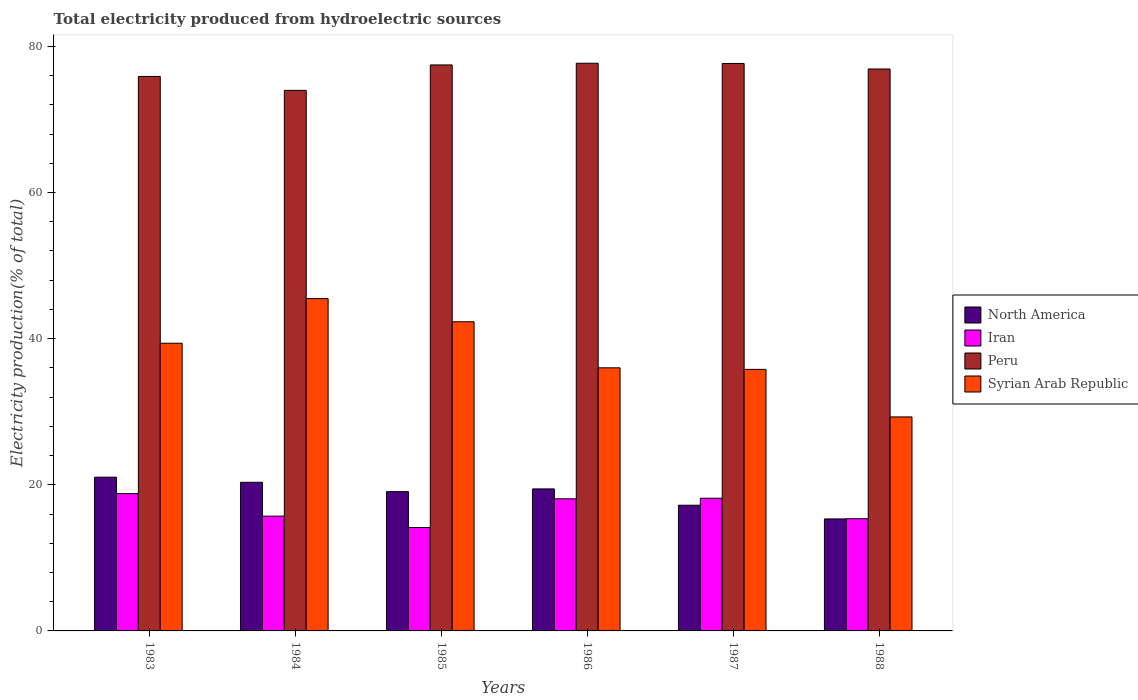How many different coloured bars are there?
Provide a short and direct response. 4. How many groups of bars are there?
Your answer should be compact. 6. Are the number of bars per tick equal to the number of legend labels?
Offer a very short reply. Yes. Are the number of bars on each tick of the X-axis equal?
Make the answer very short. Yes. How many bars are there on the 3rd tick from the right?
Your answer should be compact. 4. In how many cases, is the number of bars for a given year not equal to the number of legend labels?
Your answer should be very brief. 0. What is the total electricity produced in Iran in 1988?
Your answer should be compact. 15.36. Across all years, what is the maximum total electricity produced in Syrian Arab Republic?
Keep it short and to the point. 45.49. Across all years, what is the minimum total electricity produced in Syrian Arab Republic?
Ensure brevity in your answer.  29.29. What is the total total electricity produced in Iran in the graph?
Keep it short and to the point. 100.26. What is the difference between the total electricity produced in Iran in 1983 and that in 1986?
Offer a very short reply. 0.71. What is the difference between the total electricity produced in North America in 1987 and the total electricity produced in Iran in 1985?
Offer a terse response. 3.05. What is the average total electricity produced in Syrian Arab Republic per year?
Offer a very short reply. 38.05. In the year 1983, what is the difference between the total electricity produced in Syrian Arab Republic and total electricity produced in Iran?
Offer a terse response. 20.58. What is the ratio of the total electricity produced in Iran in 1984 to that in 1987?
Your answer should be compact. 0.87. Is the difference between the total electricity produced in Syrian Arab Republic in 1983 and 1985 greater than the difference between the total electricity produced in Iran in 1983 and 1985?
Your answer should be very brief. No. What is the difference between the highest and the second highest total electricity produced in Peru?
Offer a very short reply. 0.03. What is the difference between the highest and the lowest total electricity produced in Peru?
Your response must be concise. 3.71. Is it the case that in every year, the sum of the total electricity produced in Iran and total electricity produced in North America is greater than the sum of total electricity produced in Peru and total electricity produced in Syrian Arab Republic?
Offer a terse response. No. Is it the case that in every year, the sum of the total electricity produced in Peru and total electricity produced in Syrian Arab Republic is greater than the total electricity produced in Iran?
Offer a terse response. Yes. What is the difference between two consecutive major ticks on the Y-axis?
Your answer should be compact. 20. Does the graph contain any zero values?
Your answer should be very brief. No. Does the graph contain grids?
Your answer should be very brief. No. What is the title of the graph?
Offer a terse response. Total electricity produced from hydroelectric sources. Does "Virgin Islands" appear as one of the legend labels in the graph?
Provide a short and direct response. No. What is the label or title of the Y-axis?
Make the answer very short. Electricity production(% of total). What is the Electricity production(% of total) of North America in 1983?
Ensure brevity in your answer.  21.04. What is the Electricity production(% of total) in Iran in 1983?
Offer a very short reply. 18.79. What is the Electricity production(% of total) of Peru in 1983?
Your response must be concise. 75.89. What is the Electricity production(% of total) in Syrian Arab Republic in 1983?
Ensure brevity in your answer.  39.38. What is the Electricity production(% of total) of North America in 1984?
Keep it short and to the point. 20.34. What is the Electricity production(% of total) in Iran in 1984?
Give a very brief answer. 15.71. What is the Electricity production(% of total) of Peru in 1984?
Ensure brevity in your answer.  73.99. What is the Electricity production(% of total) in Syrian Arab Republic in 1984?
Offer a very short reply. 45.49. What is the Electricity production(% of total) in North America in 1985?
Make the answer very short. 19.06. What is the Electricity production(% of total) of Iran in 1985?
Offer a very short reply. 14.15. What is the Electricity production(% of total) in Peru in 1985?
Your answer should be very brief. 77.47. What is the Electricity production(% of total) in Syrian Arab Republic in 1985?
Your response must be concise. 42.31. What is the Electricity production(% of total) of North America in 1986?
Ensure brevity in your answer.  19.44. What is the Electricity production(% of total) in Iran in 1986?
Your answer should be compact. 18.08. What is the Electricity production(% of total) in Peru in 1986?
Keep it short and to the point. 77.7. What is the Electricity production(% of total) in Syrian Arab Republic in 1986?
Ensure brevity in your answer.  36.01. What is the Electricity production(% of total) of North America in 1987?
Your answer should be very brief. 17.2. What is the Electricity production(% of total) of Iran in 1987?
Ensure brevity in your answer.  18.16. What is the Electricity production(% of total) in Peru in 1987?
Provide a succinct answer. 77.67. What is the Electricity production(% of total) in Syrian Arab Republic in 1987?
Provide a short and direct response. 35.8. What is the Electricity production(% of total) in North America in 1988?
Make the answer very short. 15.33. What is the Electricity production(% of total) of Iran in 1988?
Offer a very short reply. 15.36. What is the Electricity production(% of total) in Peru in 1988?
Make the answer very short. 76.91. What is the Electricity production(% of total) in Syrian Arab Republic in 1988?
Provide a succinct answer. 29.29. Across all years, what is the maximum Electricity production(% of total) in North America?
Ensure brevity in your answer.  21.04. Across all years, what is the maximum Electricity production(% of total) in Iran?
Your answer should be very brief. 18.79. Across all years, what is the maximum Electricity production(% of total) of Peru?
Your answer should be compact. 77.7. Across all years, what is the maximum Electricity production(% of total) in Syrian Arab Republic?
Your answer should be compact. 45.49. Across all years, what is the minimum Electricity production(% of total) in North America?
Offer a terse response. 15.33. Across all years, what is the minimum Electricity production(% of total) in Iran?
Keep it short and to the point. 14.15. Across all years, what is the minimum Electricity production(% of total) in Peru?
Provide a short and direct response. 73.99. Across all years, what is the minimum Electricity production(% of total) of Syrian Arab Republic?
Your answer should be compact. 29.29. What is the total Electricity production(% of total) of North America in the graph?
Ensure brevity in your answer.  112.42. What is the total Electricity production(% of total) in Iran in the graph?
Your answer should be very brief. 100.26. What is the total Electricity production(% of total) of Peru in the graph?
Your response must be concise. 459.62. What is the total Electricity production(% of total) in Syrian Arab Republic in the graph?
Provide a succinct answer. 228.28. What is the difference between the Electricity production(% of total) of North America in 1983 and that in 1984?
Offer a terse response. 0.7. What is the difference between the Electricity production(% of total) in Iran in 1983 and that in 1984?
Make the answer very short. 3.08. What is the difference between the Electricity production(% of total) of Peru in 1983 and that in 1984?
Offer a very short reply. 1.91. What is the difference between the Electricity production(% of total) of Syrian Arab Republic in 1983 and that in 1984?
Offer a very short reply. -6.11. What is the difference between the Electricity production(% of total) in North America in 1983 and that in 1985?
Offer a very short reply. 1.98. What is the difference between the Electricity production(% of total) of Iran in 1983 and that in 1985?
Your answer should be compact. 4.64. What is the difference between the Electricity production(% of total) of Peru in 1983 and that in 1985?
Make the answer very short. -1.57. What is the difference between the Electricity production(% of total) in Syrian Arab Republic in 1983 and that in 1985?
Your response must be concise. -2.94. What is the difference between the Electricity production(% of total) in North America in 1983 and that in 1986?
Make the answer very short. 1.61. What is the difference between the Electricity production(% of total) of Iran in 1983 and that in 1986?
Offer a very short reply. 0.71. What is the difference between the Electricity production(% of total) of Peru in 1983 and that in 1986?
Your answer should be compact. -1.8. What is the difference between the Electricity production(% of total) of Syrian Arab Republic in 1983 and that in 1986?
Your answer should be compact. 3.37. What is the difference between the Electricity production(% of total) in North America in 1983 and that in 1987?
Offer a terse response. 3.84. What is the difference between the Electricity production(% of total) in Iran in 1983 and that in 1987?
Your response must be concise. 0.63. What is the difference between the Electricity production(% of total) in Peru in 1983 and that in 1987?
Your response must be concise. -1.77. What is the difference between the Electricity production(% of total) of Syrian Arab Republic in 1983 and that in 1987?
Offer a terse response. 3.58. What is the difference between the Electricity production(% of total) in North America in 1983 and that in 1988?
Make the answer very short. 5.71. What is the difference between the Electricity production(% of total) in Iran in 1983 and that in 1988?
Your response must be concise. 3.43. What is the difference between the Electricity production(% of total) in Peru in 1983 and that in 1988?
Give a very brief answer. -1.02. What is the difference between the Electricity production(% of total) of Syrian Arab Republic in 1983 and that in 1988?
Offer a terse response. 10.09. What is the difference between the Electricity production(% of total) in North America in 1984 and that in 1985?
Give a very brief answer. 1.28. What is the difference between the Electricity production(% of total) of Iran in 1984 and that in 1985?
Make the answer very short. 1.56. What is the difference between the Electricity production(% of total) in Peru in 1984 and that in 1985?
Ensure brevity in your answer.  -3.48. What is the difference between the Electricity production(% of total) in Syrian Arab Republic in 1984 and that in 1985?
Your answer should be very brief. 3.17. What is the difference between the Electricity production(% of total) of North America in 1984 and that in 1986?
Provide a succinct answer. 0.91. What is the difference between the Electricity production(% of total) of Iran in 1984 and that in 1986?
Your response must be concise. -2.37. What is the difference between the Electricity production(% of total) in Peru in 1984 and that in 1986?
Your answer should be very brief. -3.71. What is the difference between the Electricity production(% of total) of Syrian Arab Republic in 1984 and that in 1986?
Your response must be concise. 9.47. What is the difference between the Electricity production(% of total) of North America in 1984 and that in 1987?
Your response must be concise. 3.14. What is the difference between the Electricity production(% of total) of Iran in 1984 and that in 1987?
Your response must be concise. -2.45. What is the difference between the Electricity production(% of total) of Peru in 1984 and that in 1987?
Provide a short and direct response. -3.68. What is the difference between the Electricity production(% of total) of Syrian Arab Republic in 1984 and that in 1987?
Ensure brevity in your answer.  9.69. What is the difference between the Electricity production(% of total) in North America in 1984 and that in 1988?
Give a very brief answer. 5.01. What is the difference between the Electricity production(% of total) of Iran in 1984 and that in 1988?
Your response must be concise. 0.35. What is the difference between the Electricity production(% of total) of Peru in 1984 and that in 1988?
Provide a short and direct response. -2.92. What is the difference between the Electricity production(% of total) of Syrian Arab Republic in 1984 and that in 1988?
Ensure brevity in your answer.  16.2. What is the difference between the Electricity production(% of total) in North America in 1985 and that in 1986?
Ensure brevity in your answer.  -0.37. What is the difference between the Electricity production(% of total) in Iran in 1985 and that in 1986?
Ensure brevity in your answer.  -3.93. What is the difference between the Electricity production(% of total) in Peru in 1985 and that in 1986?
Provide a succinct answer. -0.23. What is the difference between the Electricity production(% of total) of Syrian Arab Republic in 1985 and that in 1986?
Offer a very short reply. 6.3. What is the difference between the Electricity production(% of total) in North America in 1985 and that in 1987?
Offer a very short reply. 1.86. What is the difference between the Electricity production(% of total) of Iran in 1985 and that in 1987?
Provide a short and direct response. -4.01. What is the difference between the Electricity production(% of total) in Peru in 1985 and that in 1987?
Provide a succinct answer. -0.2. What is the difference between the Electricity production(% of total) in Syrian Arab Republic in 1985 and that in 1987?
Provide a succinct answer. 6.52. What is the difference between the Electricity production(% of total) in North America in 1985 and that in 1988?
Your answer should be compact. 3.74. What is the difference between the Electricity production(% of total) of Iran in 1985 and that in 1988?
Make the answer very short. -1.21. What is the difference between the Electricity production(% of total) in Peru in 1985 and that in 1988?
Your answer should be very brief. 0.56. What is the difference between the Electricity production(% of total) in Syrian Arab Republic in 1985 and that in 1988?
Make the answer very short. 13.02. What is the difference between the Electricity production(% of total) in North America in 1986 and that in 1987?
Offer a very short reply. 2.23. What is the difference between the Electricity production(% of total) of Iran in 1986 and that in 1987?
Offer a terse response. -0.08. What is the difference between the Electricity production(% of total) in Peru in 1986 and that in 1987?
Your response must be concise. 0.03. What is the difference between the Electricity production(% of total) of Syrian Arab Republic in 1986 and that in 1987?
Offer a terse response. 0.21. What is the difference between the Electricity production(% of total) of North America in 1986 and that in 1988?
Ensure brevity in your answer.  4.11. What is the difference between the Electricity production(% of total) of Iran in 1986 and that in 1988?
Make the answer very short. 2.72. What is the difference between the Electricity production(% of total) in Peru in 1986 and that in 1988?
Make the answer very short. 0.78. What is the difference between the Electricity production(% of total) in Syrian Arab Republic in 1986 and that in 1988?
Your response must be concise. 6.72. What is the difference between the Electricity production(% of total) in North America in 1987 and that in 1988?
Your response must be concise. 1.87. What is the difference between the Electricity production(% of total) of Iran in 1987 and that in 1988?
Give a very brief answer. 2.8. What is the difference between the Electricity production(% of total) of Peru in 1987 and that in 1988?
Make the answer very short. 0.76. What is the difference between the Electricity production(% of total) of Syrian Arab Republic in 1987 and that in 1988?
Your response must be concise. 6.51. What is the difference between the Electricity production(% of total) of North America in 1983 and the Electricity production(% of total) of Iran in 1984?
Give a very brief answer. 5.33. What is the difference between the Electricity production(% of total) in North America in 1983 and the Electricity production(% of total) in Peru in 1984?
Give a very brief answer. -52.94. What is the difference between the Electricity production(% of total) of North America in 1983 and the Electricity production(% of total) of Syrian Arab Republic in 1984?
Make the answer very short. -24.44. What is the difference between the Electricity production(% of total) of Iran in 1983 and the Electricity production(% of total) of Peru in 1984?
Offer a very short reply. -55.19. What is the difference between the Electricity production(% of total) in Iran in 1983 and the Electricity production(% of total) in Syrian Arab Republic in 1984?
Provide a short and direct response. -26.69. What is the difference between the Electricity production(% of total) in Peru in 1983 and the Electricity production(% of total) in Syrian Arab Republic in 1984?
Your answer should be compact. 30.41. What is the difference between the Electricity production(% of total) of North America in 1983 and the Electricity production(% of total) of Iran in 1985?
Offer a very short reply. 6.89. What is the difference between the Electricity production(% of total) of North America in 1983 and the Electricity production(% of total) of Peru in 1985?
Give a very brief answer. -56.42. What is the difference between the Electricity production(% of total) in North America in 1983 and the Electricity production(% of total) in Syrian Arab Republic in 1985?
Keep it short and to the point. -21.27. What is the difference between the Electricity production(% of total) of Iran in 1983 and the Electricity production(% of total) of Peru in 1985?
Provide a succinct answer. -58.67. What is the difference between the Electricity production(% of total) in Iran in 1983 and the Electricity production(% of total) in Syrian Arab Republic in 1985?
Give a very brief answer. -23.52. What is the difference between the Electricity production(% of total) of Peru in 1983 and the Electricity production(% of total) of Syrian Arab Republic in 1985?
Offer a terse response. 33.58. What is the difference between the Electricity production(% of total) of North America in 1983 and the Electricity production(% of total) of Iran in 1986?
Ensure brevity in your answer.  2.96. What is the difference between the Electricity production(% of total) of North America in 1983 and the Electricity production(% of total) of Peru in 1986?
Your answer should be compact. -56.65. What is the difference between the Electricity production(% of total) in North America in 1983 and the Electricity production(% of total) in Syrian Arab Republic in 1986?
Provide a short and direct response. -14.97. What is the difference between the Electricity production(% of total) of Iran in 1983 and the Electricity production(% of total) of Peru in 1986?
Your answer should be compact. -58.9. What is the difference between the Electricity production(% of total) in Iran in 1983 and the Electricity production(% of total) in Syrian Arab Republic in 1986?
Keep it short and to the point. -17.22. What is the difference between the Electricity production(% of total) in Peru in 1983 and the Electricity production(% of total) in Syrian Arab Republic in 1986?
Give a very brief answer. 39.88. What is the difference between the Electricity production(% of total) in North America in 1983 and the Electricity production(% of total) in Iran in 1987?
Give a very brief answer. 2.88. What is the difference between the Electricity production(% of total) in North America in 1983 and the Electricity production(% of total) in Peru in 1987?
Keep it short and to the point. -56.62. What is the difference between the Electricity production(% of total) in North America in 1983 and the Electricity production(% of total) in Syrian Arab Republic in 1987?
Make the answer very short. -14.76. What is the difference between the Electricity production(% of total) in Iran in 1983 and the Electricity production(% of total) in Peru in 1987?
Offer a very short reply. -58.87. What is the difference between the Electricity production(% of total) in Iran in 1983 and the Electricity production(% of total) in Syrian Arab Republic in 1987?
Provide a short and direct response. -17.01. What is the difference between the Electricity production(% of total) in Peru in 1983 and the Electricity production(% of total) in Syrian Arab Republic in 1987?
Your answer should be compact. 40.09. What is the difference between the Electricity production(% of total) of North America in 1983 and the Electricity production(% of total) of Iran in 1988?
Your answer should be compact. 5.68. What is the difference between the Electricity production(% of total) in North America in 1983 and the Electricity production(% of total) in Peru in 1988?
Offer a terse response. -55.87. What is the difference between the Electricity production(% of total) of North America in 1983 and the Electricity production(% of total) of Syrian Arab Republic in 1988?
Your answer should be very brief. -8.25. What is the difference between the Electricity production(% of total) of Iran in 1983 and the Electricity production(% of total) of Peru in 1988?
Provide a succinct answer. -58.12. What is the difference between the Electricity production(% of total) of Iran in 1983 and the Electricity production(% of total) of Syrian Arab Republic in 1988?
Give a very brief answer. -10.5. What is the difference between the Electricity production(% of total) in Peru in 1983 and the Electricity production(% of total) in Syrian Arab Republic in 1988?
Offer a very short reply. 46.6. What is the difference between the Electricity production(% of total) of North America in 1984 and the Electricity production(% of total) of Iran in 1985?
Your response must be concise. 6.19. What is the difference between the Electricity production(% of total) of North America in 1984 and the Electricity production(% of total) of Peru in 1985?
Your response must be concise. -57.12. What is the difference between the Electricity production(% of total) of North America in 1984 and the Electricity production(% of total) of Syrian Arab Republic in 1985?
Your response must be concise. -21.97. What is the difference between the Electricity production(% of total) in Iran in 1984 and the Electricity production(% of total) in Peru in 1985?
Give a very brief answer. -61.75. What is the difference between the Electricity production(% of total) of Iran in 1984 and the Electricity production(% of total) of Syrian Arab Republic in 1985?
Your answer should be very brief. -26.6. What is the difference between the Electricity production(% of total) of Peru in 1984 and the Electricity production(% of total) of Syrian Arab Republic in 1985?
Provide a short and direct response. 31.67. What is the difference between the Electricity production(% of total) in North America in 1984 and the Electricity production(% of total) in Iran in 1986?
Ensure brevity in your answer.  2.26. What is the difference between the Electricity production(% of total) of North America in 1984 and the Electricity production(% of total) of Peru in 1986?
Give a very brief answer. -57.35. What is the difference between the Electricity production(% of total) in North America in 1984 and the Electricity production(% of total) in Syrian Arab Republic in 1986?
Provide a short and direct response. -15.67. What is the difference between the Electricity production(% of total) of Iran in 1984 and the Electricity production(% of total) of Peru in 1986?
Provide a succinct answer. -61.98. What is the difference between the Electricity production(% of total) in Iran in 1984 and the Electricity production(% of total) in Syrian Arab Republic in 1986?
Give a very brief answer. -20.3. What is the difference between the Electricity production(% of total) in Peru in 1984 and the Electricity production(% of total) in Syrian Arab Republic in 1986?
Ensure brevity in your answer.  37.98. What is the difference between the Electricity production(% of total) of North America in 1984 and the Electricity production(% of total) of Iran in 1987?
Your response must be concise. 2.18. What is the difference between the Electricity production(% of total) of North America in 1984 and the Electricity production(% of total) of Peru in 1987?
Your response must be concise. -57.32. What is the difference between the Electricity production(% of total) of North America in 1984 and the Electricity production(% of total) of Syrian Arab Republic in 1987?
Keep it short and to the point. -15.46. What is the difference between the Electricity production(% of total) in Iran in 1984 and the Electricity production(% of total) in Peru in 1987?
Ensure brevity in your answer.  -61.95. What is the difference between the Electricity production(% of total) in Iran in 1984 and the Electricity production(% of total) in Syrian Arab Republic in 1987?
Your answer should be compact. -20.09. What is the difference between the Electricity production(% of total) in Peru in 1984 and the Electricity production(% of total) in Syrian Arab Republic in 1987?
Provide a short and direct response. 38.19. What is the difference between the Electricity production(% of total) of North America in 1984 and the Electricity production(% of total) of Iran in 1988?
Your response must be concise. 4.98. What is the difference between the Electricity production(% of total) of North America in 1984 and the Electricity production(% of total) of Peru in 1988?
Give a very brief answer. -56.57. What is the difference between the Electricity production(% of total) in North America in 1984 and the Electricity production(% of total) in Syrian Arab Republic in 1988?
Make the answer very short. -8.95. What is the difference between the Electricity production(% of total) of Iran in 1984 and the Electricity production(% of total) of Peru in 1988?
Make the answer very short. -61.2. What is the difference between the Electricity production(% of total) of Iran in 1984 and the Electricity production(% of total) of Syrian Arab Republic in 1988?
Offer a terse response. -13.58. What is the difference between the Electricity production(% of total) in Peru in 1984 and the Electricity production(% of total) in Syrian Arab Republic in 1988?
Offer a very short reply. 44.7. What is the difference between the Electricity production(% of total) in North America in 1985 and the Electricity production(% of total) in Iran in 1986?
Your answer should be compact. 0.98. What is the difference between the Electricity production(% of total) of North America in 1985 and the Electricity production(% of total) of Peru in 1986?
Your answer should be very brief. -58.63. What is the difference between the Electricity production(% of total) of North America in 1985 and the Electricity production(% of total) of Syrian Arab Republic in 1986?
Offer a terse response. -16.95. What is the difference between the Electricity production(% of total) in Iran in 1985 and the Electricity production(% of total) in Peru in 1986?
Make the answer very short. -63.54. What is the difference between the Electricity production(% of total) of Iran in 1985 and the Electricity production(% of total) of Syrian Arab Republic in 1986?
Give a very brief answer. -21.86. What is the difference between the Electricity production(% of total) of Peru in 1985 and the Electricity production(% of total) of Syrian Arab Republic in 1986?
Your answer should be compact. 41.46. What is the difference between the Electricity production(% of total) of North America in 1985 and the Electricity production(% of total) of Iran in 1987?
Give a very brief answer. 0.9. What is the difference between the Electricity production(% of total) in North America in 1985 and the Electricity production(% of total) in Peru in 1987?
Provide a succinct answer. -58.6. What is the difference between the Electricity production(% of total) in North America in 1985 and the Electricity production(% of total) in Syrian Arab Republic in 1987?
Keep it short and to the point. -16.73. What is the difference between the Electricity production(% of total) of Iran in 1985 and the Electricity production(% of total) of Peru in 1987?
Give a very brief answer. -63.52. What is the difference between the Electricity production(% of total) in Iran in 1985 and the Electricity production(% of total) in Syrian Arab Republic in 1987?
Make the answer very short. -21.65. What is the difference between the Electricity production(% of total) in Peru in 1985 and the Electricity production(% of total) in Syrian Arab Republic in 1987?
Your answer should be compact. 41.67. What is the difference between the Electricity production(% of total) of North America in 1985 and the Electricity production(% of total) of Iran in 1988?
Offer a terse response. 3.71. What is the difference between the Electricity production(% of total) in North America in 1985 and the Electricity production(% of total) in Peru in 1988?
Offer a terse response. -57.85. What is the difference between the Electricity production(% of total) in North America in 1985 and the Electricity production(% of total) in Syrian Arab Republic in 1988?
Keep it short and to the point. -10.23. What is the difference between the Electricity production(% of total) of Iran in 1985 and the Electricity production(% of total) of Peru in 1988?
Your answer should be very brief. -62.76. What is the difference between the Electricity production(% of total) in Iran in 1985 and the Electricity production(% of total) in Syrian Arab Republic in 1988?
Give a very brief answer. -15.14. What is the difference between the Electricity production(% of total) in Peru in 1985 and the Electricity production(% of total) in Syrian Arab Republic in 1988?
Provide a succinct answer. 48.18. What is the difference between the Electricity production(% of total) in North America in 1986 and the Electricity production(% of total) in Iran in 1987?
Provide a succinct answer. 1.28. What is the difference between the Electricity production(% of total) of North America in 1986 and the Electricity production(% of total) of Peru in 1987?
Provide a short and direct response. -58.23. What is the difference between the Electricity production(% of total) of North America in 1986 and the Electricity production(% of total) of Syrian Arab Republic in 1987?
Make the answer very short. -16.36. What is the difference between the Electricity production(% of total) in Iran in 1986 and the Electricity production(% of total) in Peru in 1987?
Your answer should be compact. -59.58. What is the difference between the Electricity production(% of total) of Iran in 1986 and the Electricity production(% of total) of Syrian Arab Republic in 1987?
Your response must be concise. -17.72. What is the difference between the Electricity production(% of total) of Peru in 1986 and the Electricity production(% of total) of Syrian Arab Republic in 1987?
Offer a very short reply. 41.9. What is the difference between the Electricity production(% of total) of North America in 1986 and the Electricity production(% of total) of Iran in 1988?
Give a very brief answer. 4.08. What is the difference between the Electricity production(% of total) of North America in 1986 and the Electricity production(% of total) of Peru in 1988?
Keep it short and to the point. -57.47. What is the difference between the Electricity production(% of total) in North America in 1986 and the Electricity production(% of total) in Syrian Arab Republic in 1988?
Ensure brevity in your answer.  -9.85. What is the difference between the Electricity production(% of total) in Iran in 1986 and the Electricity production(% of total) in Peru in 1988?
Make the answer very short. -58.83. What is the difference between the Electricity production(% of total) in Iran in 1986 and the Electricity production(% of total) in Syrian Arab Republic in 1988?
Provide a succinct answer. -11.21. What is the difference between the Electricity production(% of total) of Peru in 1986 and the Electricity production(% of total) of Syrian Arab Republic in 1988?
Provide a short and direct response. 48.4. What is the difference between the Electricity production(% of total) in North America in 1987 and the Electricity production(% of total) in Iran in 1988?
Your answer should be compact. 1.84. What is the difference between the Electricity production(% of total) in North America in 1987 and the Electricity production(% of total) in Peru in 1988?
Your answer should be compact. -59.71. What is the difference between the Electricity production(% of total) in North America in 1987 and the Electricity production(% of total) in Syrian Arab Republic in 1988?
Keep it short and to the point. -12.09. What is the difference between the Electricity production(% of total) of Iran in 1987 and the Electricity production(% of total) of Peru in 1988?
Your answer should be very brief. -58.75. What is the difference between the Electricity production(% of total) in Iran in 1987 and the Electricity production(% of total) in Syrian Arab Republic in 1988?
Your response must be concise. -11.13. What is the difference between the Electricity production(% of total) in Peru in 1987 and the Electricity production(% of total) in Syrian Arab Republic in 1988?
Give a very brief answer. 48.38. What is the average Electricity production(% of total) of North America per year?
Your answer should be very brief. 18.74. What is the average Electricity production(% of total) in Iran per year?
Make the answer very short. 16.71. What is the average Electricity production(% of total) of Peru per year?
Make the answer very short. 76.6. What is the average Electricity production(% of total) in Syrian Arab Republic per year?
Your answer should be compact. 38.05. In the year 1983, what is the difference between the Electricity production(% of total) of North America and Electricity production(% of total) of Iran?
Give a very brief answer. 2.25. In the year 1983, what is the difference between the Electricity production(% of total) of North America and Electricity production(% of total) of Peru?
Your answer should be very brief. -54.85. In the year 1983, what is the difference between the Electricity production(% of total) in North America and Electricity production(% of total) in Syrian Arab Republic?
Offer a terse response. -18.33. In the year 1983, what is the difference between the Electricity production(% of total) in Iran and Electricity production(% of total) in Peru?
Your response must be concise. -57.1. In the year 1983, what is the difference between the Electricity production(% of total) of Iran and Electricity production(% of total) of Syrian Arab Republic?
Provide a short and direct response. -20.58. In the year 1983, what is the difference between the Electricity production(% of total) of Peru and Electricity production(% of total) of Syrian Arab Republic?
Keep it short and to the point. 36.52. In the year 1984, what is the difference between the Electricity production(% of total) of North America and Electricity production(% of total) of Iran?
Make the answer very short. 4.63. In the year 1984, what is the difference between the Electricity production(% of total) in North America and Electricity production(% of total) in Peru?
Offer a very short reply. -53.64. In the year 1984, what is the difference between the Electricity production(% of total) of North America and Electricity production(% of total) of Syrian Arab Republic?
Your answer should be compact. -25.14. In the year 1984, what is the difference between the Electricity production(% of total) of Iran and Electricity production(% of total) of Peru?
Your response must be concise. -58.27. In the year 1984, what is the difference between the Electricity production(% of total) in Iran and Electricity production(% of total) in Syrian Arab Republic?
Give a very brief answer. -29.77. In the year 1984, what is the difference between the Electricity production(% of total) of Peru and Electricity production(% of total) of Syrian Arab Republic?
Your answer should be compact. 28.5. In the year 1985, what is the difference between the Electricity production(% of total) in North America and Electricity production(% of total) in Iran?
Keep it short and to the point. 4.91. In the year 1985, what is the difference between the Electricity production(% of total) in North America and Electricity production(% of total) in Peru?
Your response must be concise. -58.4. In the year 1985, what is the difference between the Electricity production(% of total) of North America and Electricity production(% of total) of Syrian Arab Republic?
Offer a very short reply. -23.25. In the year 1985, what is the difference between the Electricity production(% of total) in Iran and Electricity production(% of total) in Peru?
Provide a short and direct response. -63.32. In the year 1985, what is the difference between the Electricity production(% of total) in Iran and Electricity production(% of total) in Syrian Arab Republic?
Provide a succinct answer. -28.16. In the year 1985, what is the difference between the Electricity production(% of total) in Peru and Electricity production(% of total) in Syrian Arab Republic?
Your response must be concise. 35.15. In the year 1986, what is the difference between the Electricity production(% of total) of North America and Electricity production(% of total) of Iran?
Keep it short and to the point. 1.35. In the year 1986, what is the difference between the Electricity production(% of total) of North America and Electricity production(% of total) of Peru?
Provide a succinct answer. -58.26. In the year 1986, what is the difference between the Electricity production(% of total) of North America and Electricity production(% of total) of Syrian Arab Republic?
Provide a short and direct response. -16.57. In the year 1986, what is the difference between the Electricity production(% of total) in Iran and Electricity production(% of total) in Peru?
Give a very brief answer. -59.61. In the year 1986, what is the difference between the Electricity production(% of total) of Iran and Electricity production(% of total) of Syrian Arab Republic?
Ensure brevity in your answer.  -17.93. In the year 1986, what is the difference between the Electricity production(% of total) in Peru and Electricity production(% of total) in Syrian Arab Republic?
Give a very brief answer. 41.68. In the year 1987, what is the difference between the Electricity production(% of total) of North America and Electricity production(% of total) of Iran?
Make the answer very short. -0.96. In the year 1987, what is the difference between the Electricity production(% of total) of North America and Electricity production(% of total) of Peru?
Your answer should be compact. -60.46. In the year 1987, what is the difference between the Electricity production(% of total) in North America and Electricity production(% of total) in Syrian Arab Republic?
Your answer should be very brief. -18.6. In the year 1987, what is the difference between the Electricity production(% of total) in Iran and Electricity production(% of total) in Peru?
Make the answer very short. -59.51. In the year 1987, what is the difference between the Electricity production(% of total) in Iran and Electricity production(% of total) in Syrian Arab Republic?
Provide a short and direct response. -17.64. In the year 1987, what is the difference between the Electricity production(% of total) of Peru and Electricity production(% of total) of Syrian Arab Republic?
Give a very brief answer. 41.87. In the year 1988, what is the difference between the Electricity production(% of total) of North America and Electricity production(% of total) of Iran?
Keep it short and to the point. -0.03. In the year 1988, what is the difference between the Electricity production(% of total) of North America and Electricity production(% of total) of Peru?
Your answer should be compact. -61.58. In the year 1988, what is the difference between the Electricity production(% of total) in North America and Electricity production(% of total) in Syrian Arab Republic?
Keep it short and to the point. -13.96. In the year 1988, what is the difference between the Electricity production(% of total) in Iran and Electricity production(% of total) in Peru?
Offer a very short reply. -61.55. In the year 1988, what is the difference between the Electricity production(% of total) in Iran and Electricity production(% of total) in Syrian Arab Republic?
Make the answer very short. -13.93. In the year 1988, what is the difference between the Electricity production(% of total) of Peru and Electricity production(% of total) of Syrian Arab Republic?
Make the answer very short. 47.62. What is the ratio of the Electricity production(% of total) in North America in 1983 to that in 1984?
Offer a terse response. 1.03. What is the ratio of the Electricity production(% of total) of Iran in 1983 to that in 1984?
Your answer should be compact. 1.2. What is the ratio of the Electricity production(% of total) of Peru in 1983 to that in 1984?
Keep it short and to the point. 1.03. What is the ratio of the Electricity production(% of total) in Syrian Arab Republic in 1983 to that in 1984?
Make the answer very short. 0.87. What is the ratio of the Electricity production(% of total) in North America in 1983 to that in 1985?
Keep it short and to the point. 1.1. What is the ratio of the Electricity production(% of total) in Iran in 1983 to that in 1985?
Provide a short and direct response. 1.33. What is the ratio of the Electricity production(% of total) in Peru in 1983 to that in 1985?
Your response must be concise. 0.98. What is the ratio of the Electricity production(% of total) of Syrian Arab Republic in 1983 to that in 1985?
Your answer should be compact. 0.93. What is the ratio of the Electricity production(% of total) of North America in 1983 to that in 1986?
Your answer should be very brief. 1.08. What is the ratio of the Electricity production(% of total) of Iran in 1983 to that in 1986?
Provide a short and direct response. 1.04. What is the ratio of the Electricity production(% of total) in Peru in 1983 to that in 1986?
Keep it short and to the point. 0.98. What is the ratio of the Electricity production(% of total) of Syrian Arab Republic in 1983 to that in 1986?
Ensure brevity in your answer.  1.09. What is the ratio of the Electricity production(% of total) of North America in 1983 to that in 1987?
Keep it short and to the point. 1.22. What is the ratio of the Electricity production(% of total) of Iran in 1983 to that in 1987?
Make the answer very short. 1.03. What is the ratio of the Electricity production(% of total) in Peru in 1983 to that in 1987?
Provide a succinct answer. 0.98. What is the ratio of the Electricity production(% of total) of Syrian Arab Republic in 1983 to that in 1987?
Ensure brevity in your answer.  1.1. What is the ratio of the Electricity production(% of total) of North America in 1983 to that in 1988?
Your answer should be compact. 1.37. What is the ratio of the Electricity production(% of total) of Iran in 1983 to that in 1988?
Offer a terse response. 1.22. What is the ratio of the Electricity production(% of total) of Peru in 1983 to that in 1988?
Keep it short and to the point. 0.99. What is the ratio of the Electricity production(% of total) of Syrian Arab Republic in 1983 to that in 1988?
Offer a very short reply. 1.34. What is the ratio of the Electricity production(% of total) of North America in 1984 to that in 1985?
Provide a succinct answer. 1.07. What is the ratio of the Electricity production(% of total) in Iran in 1984 to that in 1985?
Give a very brief answer. 1.11. What is the ratio of the Electricity production(% of total) of Peru in 1984 to that in 1985?
Your answer should be compact. 0.96. What is the ratio of the Electricity production(% of total) in Syrian Arab Republic in 1984 to that in 1985?
Make the answer very short. 1.07. What is the ratio of the Electricity production(% of total) in North America in 1984 to that in 1986?
Your answer should be compact. 1.05. What is the ratio of the Electricity production(% of total) in Iran in 1984 to that in 1986?
Ensure brevity in your answer.  0.87. What is the ratio of the Electricity production(% of total) in Peru in 1984 to that in 1986?
Your answer should be compact. 0.95. What is the ratio of the Electricity production(% of total) of Syrian Arab Republic in 1984 to that in 1986?
Make the answer very short. 1.26. What is the ratio of the Electricity production(% of total) of North America in 1984 to that in 1987?
Your answer should be very brief. 1.18. What is the ratio of the Electricity production(% of total) in Iran in 1984 to that in 1987?
Your answer should be compact. 0.87. What is the ratio of the Electricity production(% of total) in Peru in 1984 to that in 1987?
Ensure brevity in your answer.  0.95. What is the ratio of the Electricity production(% of total) in Syrian Arab Republic in 1984 to that in 1987?
Offer a very short reply. 1.27. What is the ratio of the Electricity production(% of total) in North America in 1984 to that in 1988?
Provide a succinct answer. 1.33. What is the ratio of the Electricity production(% of total) of Iran in 1984 to that in 1988?
Provide a succinct answer. 1.02. What is the ratio of the Electricity production(% of total) in Syrian Arab Republic in 1984 to that in 1988?
Provide a short and direct response. 1.55. What is the ratio of the Electricity production(% of total) of North America in 1985 to that in 1986?
Your answer should be very brief. 0.98. What is the ratio of the Electricity production(% of total) of Iran in 1985 to that in 1986?
Make the answer very short. 0.78. What is the ratio of the Electricity production(% of total) in Syrian Arab Republic in 1985 to that in 1986?
Ensure brevity in your answer.  1.18. What is the ratio of the Electricity production(% of total) of North America in 1985 to that in 1987?
Offer a terse response. 1.11. What is the ratio of the Electricity production(% of total) of Iran in 1985 to that in 1987?
Give a very brief answer. 0.78. What is the ratio of the Electricity production(% of total) of Peru in 1985 to that in 1987?
Keep it short and to the point. 1. What is the ratio of the Electricity production(% of total) of Syrian Arab Republic in 1985 to that in 1987?
Provide a short and direct response. 1.18. What is the ratio of the Electricity production(% of total) of North America in 1985 to that in 1988?
Offer a very short reply. 1.24. What is the ratio of the Electricity production(% of total) in Iran in 1985 to that in 1988?
Provide a short and direct response. 0.92. What is the ratio of the Electricity production(% of total) in Syrian Arab Republic in 1985 to that in 1988?
Offer a terse response. 1.44. What is the ratio of the Electricity production(% of total) in North America in 1986 to that in 1987?
Provide a succinct answer. 1.13. What is the ratio of the Electricity production(% of total) of Peru in 1986 to that in 1987?
Offer a terse response. 1. What is the ratio of the Electricity production(% of total) of Syrian Arab Republic in 1986 to that in 1987?
Provide a succinct answer. 1.01. What is the ratio of the Electricity production(% of total) in North America in 1986 to that in 1988?
Give a very brief answer. 1.27. What is the ratio of the Electricity production(% of total) of Iran in 1986 to that in 1988?
Your answer should be very brief. 1.18. What is the ratio of the Electricity production(% of total) in Peru in 1986 to that in 1988?
Keep it short and to the point. 1.01. What is the ratio of the Electricity production(% of total) of Syrian Arab Republic in 1986 to that in 1988?
Provide a short and direct response. 1.23. What is the ratio of the Electricity production(% of total) in North America in 1987 to that in 1988?
Your response must be concise. 1.12. What is the ratio of the Electricity production(% of total) in Iran in 1987 to that in 1988?
Ensure brevity in your answer.  1.18. What is the ratio of the Electricity production(% of total) of Peru in 1987 to that in 1988?
Your response must be concise. 1.01. What is the ratio of the Electricity production(% of total) of Syrian Arab Republic in 1987 to that in 1988?
Your response must be concise. 1.22. What is the difference between the highest and the second highest Electricity production(% of total) in North America?
Offer a very short reply. 0.7. What is the difference between the highest and the second highest Electricity production(% of total) in Iran?
Ensure brevity in your answer.  0.63. What is the difference between the highest and the second highest Electricity production(% of total) of Peru?
Provide a short and direct response. 0.03. What is the difference between the highest and the second highest Electricity production(% of total) in Syrian Arab Republic?
Your answer should be compact. 3.17. What is the difference between the highest and the lowest Electricity production(% of total) of North America?
Your answer should be compact. 5.71. What is the difference between the highest and the lowest Electricity production(% of total) in Iran?
Provide a short and direct response. 4.64. What is the difference between the highest and the lowest Electricity production(% of total) of Peru?
Ensure brevity in your answer.  3.71. What is the difference between the highest and the lowest Electricity production(% of total) in Syrian Arab Republic?
Your answer should be very brief. 16.2. 